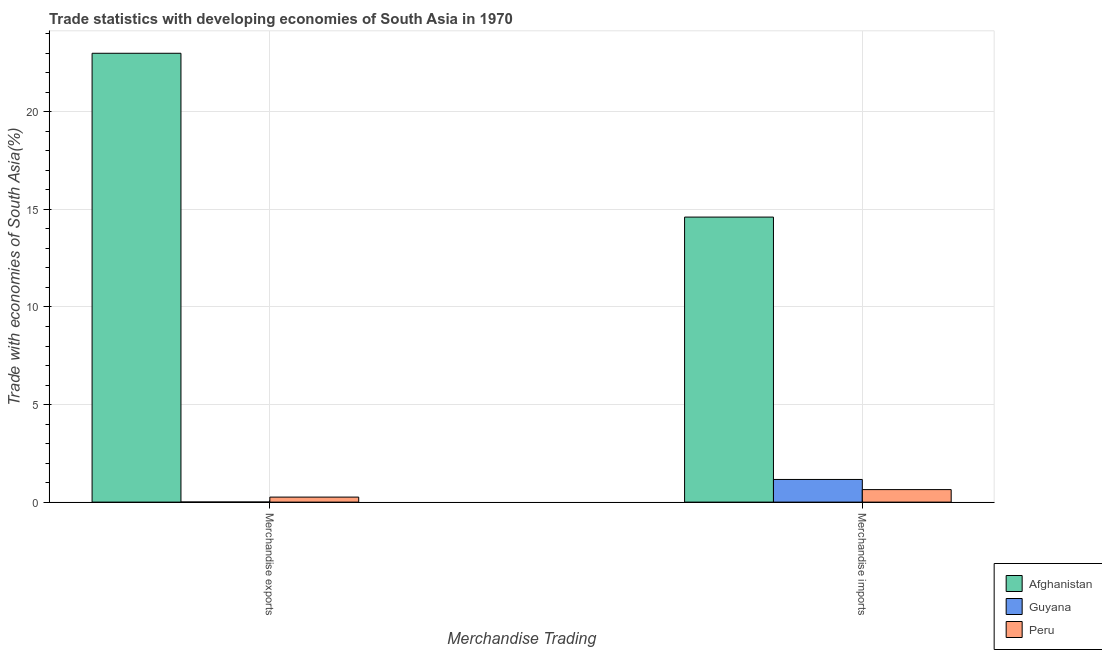How many different coloured bars are there?
Provide a succinct answer. 3. Are the number of bars per tick equal to the number of legend labels?
Your response must be concise. Yes. How many bars are there on the 1st tick from the left?
Ensure brevity in your answer.  3. What is the merchandise imports in Afghanistan?
Your answer should be very brief. 14.61. Across all countries, what is the maximum merchandise imports?
Offer a terse response. 14.61. Across all countries, what is the minimum merchandise exports?
Provide a succinct answer. 0.01. In which country was the merchandise exports maximum?
Provide a succinct answer. Afghanistan. In which country was the merchandise exports minimum?
Ensure brevity in your answer.  Guyana. What is the total merchandise exports in the graph?
Keep it short and to the point. 23.27. What is the difference between the merchandise imports in Peru and that in Afghanistan?
Your answer should be very brief. -13.97. What is the difference between the merchandise imports in Guyana and the merchandise exports in Peru?
Your response must be concise. 0.9. What is the average merchandise imports per country?
Your response must be concise. 5.47. What is the difference between the merchandise imports and merchandise exports in Peru?
Make the answer very short. 0.38. What is the ratio of the merchandise exports in Peru to that in Guyana?
Offer a very short reply. 49.11. Is the merchandise exports in Afghanistan less than that in Guyana?
Your answer should be compact. No. In how many countries, is the merchandise exports greater than the average merchandise exports taken over all countries?
Offer a terse response. 1. What does the 1st bar from the left in Merchandise exports represents?
Offer a very short reply. Afghanistan. What does the 1st bar from the right in Merchandise imports represents?
Make the answer very short. Peru. How many bars are there?
Ensure brevity in your answer.  6. Are all the bars in the graph horizontal?
Provide a short and direct response. No. How many countries are there in the graph?
Give a very brief answer. 3. Are the values on the major ticks of Y-axis written in scientific E-notation?
Your response must be concise. No. Does the graph contain grids?
Make the answer very short. Yes. What is the title of the graph?
Offer a very short reply. Trade statistics with developing economies of South Asia in 1970. What is the label or title of the X-axis?
Offer a terse response. Merchandise Trading. What is the label or title of the Y-axis?
Offer a terse response. Trade with economies of South Asia(%). What is the Trade with economies of South Asia(%) in Afghanistan in Merchandise exports?
Your answer should be very brief. 23. What is the Trade with economies of South Asia(%) in Guyana in Merchandise exports?
Offer a terse response. 0.01. What is the Trade with economies of South Asia(%) in Peru in Merchandise exports?
Your response must be concise. 0.26. What is the Trade with economies of South Asia(%) of Afghanistan in Merchandise imports?
Provide a succinct answer. 14.61. What is the Trade with economies of South Asia(%) in Guyana in Merchandise imports?
Your answer should be very brief. 1.16. What is the Trade with economies of South Asia(%) in Peru in Merchandise imports?
Offer a terse response. 0.64. Across all Merchandise Trading, what is the maximum Trade with economies of South Asia(%) in Afghanistan?
Your answer should be very brief. 23. Across all Merchandise Trading, what is the maximum Trade with economies of South Asia(%) in Guyana?
Give a very brief answer. 1.16. Across all Merchandise Trading, what is the maximum Trade with economies of South Asia(%) in Peru?
Provide a succinct answer. 0.64. Across all Merchandise Trading, what is the minimum Trade with economies of South Asia(%) in Afghanistan?
Your response must be concise. 14.61. Across all Merchandise Trading, what is the minimum Trade with economies of South Asia(%) in Guyana?
Provide a short and direct response. 0.01. Across all Merchandise Trading, what is the minimum Trade with economies of South Asia(%) of Peru?
Ensure brevity in your answer.  0.26. What is the total Trade with economies of South Asia(%) in Afghanistan in the graph?
Provide a short and direct response. 37.61. What is the total Trade with economies of South Asia(%) of Guyana in the graph?
Offer a very short reply. 1.17. What is the total Trade with economies of South Asia(%) in Peru in the graph?
Your answer should be very brief. 0.9. What is the difference between the Trade with economies of South Asia(%) of Afghanistan in Merchandise exports and that in Merchandise imports?
Give a very brief answer. 8.39. What is the difference between the Trade with economies of South Asia(%) of Guyana in Merchandise exports and that in Merchandise imports?
Give a very brief answer. -1.16. What is the difference between the Trade with economies of South Asia(%) of Peru in Merchandise exports and that in Merchandise imports?
Offer a very short reply. -0.38. What is the difference between the Trade with economies of South Asia(%) of Afghanistan in Merchandise exports and the Trade with economies of South Asia(%) of Guyana in Merchandise imports?
Ensure brevity in your answer.  21.84. What is the difference between the Trade with economies of South Asia(%) in Afghanistan in Merchandise exports and the Trade with economies of South Asia(%) in Peru in Merchandise imports?
Give a very brief answer. 22.36. What is the difference between the Trade with economies of South Asia(%) of Guyana in Merchandise exports and the Trade with economies of South Asia(%) of Peru in Merchandise imports?
Give a very brief answer. -0.64. What is the average Trade with economies of South Asia(%) in Afghanistan per Merchandise Trading?
Your answer should be compact. 18.8. What is the average Trade with economies of South Asia(%) in Guyana per Merchandise Trading?
Give a very brief answer. 0.58. What is the average Trade with economies of South Asia(%) of Peru per Merchandise Trading?
Your answer should be very brief. 0.45. What is the difference between the Trade with economies of South Asia(%) in Afghanistan and Trade with economies of South Asia(%) in Guyana in Merchandise exports?
Give a very brief answer. 23. What is the difference between the Trade with economies of South Asia(%) in Afghanistan and Trade with economies of South Asia(%) in Peru in Merchandise exports?
Offer a terse response. 22.74. What is the difference between the Trade with economies of South Asia(%) in Guyana and Trade with economies of South Asia(%) in Peru in Merchandise exports?
Your answer should be very brief. -0.25. What is the difference between the Trade with economies of South Asia(%) in Afghanistan and Trade with economies of South Asia(%) in Guyana in Merchandise imports?
Make the answer very short. 13.45. What is the difference between the Trade with economies of South Asia(%) in Afghanistan and Trade with economies of South Asia(%) in Peru in Merchandise imports?
Make the answer very short. 13.97. What is the difference between the Trade with economies of South Asia(%) in Guyana and Trade with economies of South Asia(%) in Peru in Merchandise imports?
Provide a succinct answer. 0.52. What is the ratio of the Trade with economies of South Asia(%) in Afghanistan in Merchandise exports to that in Merchandise imports?
Provide a short and direct response. 1.57. What is the ratio of the Trade with economies of South Asia(%) of Guyana in Merchandise exports to that in Merchandise imports?
Ensure brevity in your answer.  0. What is the ratio of the Trade with economies of South Asia(%) in Peru in Merchandise exports to that in Merchandise imports?
Your answer should be compact. 0.4. What is the difference between the highest and the second highest Trade with economies of South Asia(%) in Afghanistan?
Keep it short and to the point. 8.39. What is the difference between the highest and the second highest Trade with economies of South Asia(%) in Guyana?
Provide a short and direct response. 1.16. What is the difference between the highest and the second highest Trade with economies of South Asia(%) of Peru?
Keep it short and to the point. 0.38. What is the difference between the highest and the lowest Trade with economies of South Asia(%) in Afghanistan?
Your response must be concise. 8.39. What is the difference between the highest and the lowest Trade with economies of South Asia(%) in Guyana?
Provide a short and direct response. 1.16. What is the difference between the highest and the lowest Trade with economies of South Asia(%) of Peru?
Your response must be concise. 0.38. 